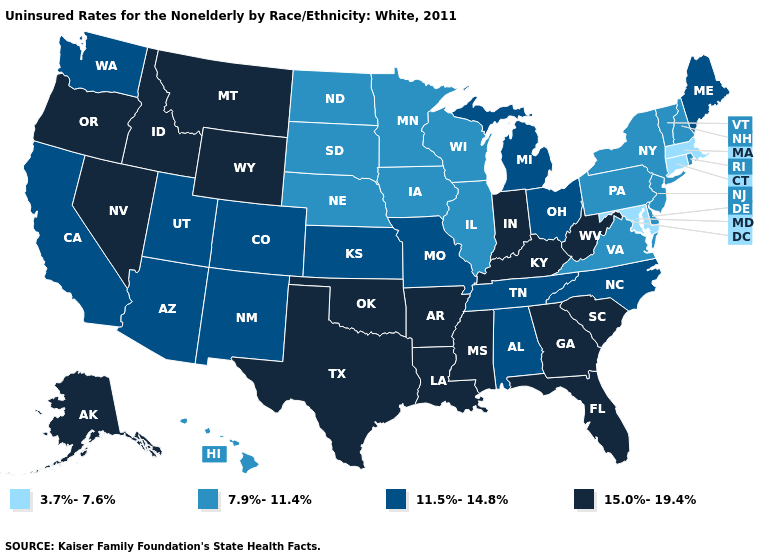What is the highest value in states that border Kansas?
Be succinct. 15.0%-19.4%. What is the highest value in the USA?
Concise answer only. 15.0%-19.4%. What is the value of Illinois?
Give a very brief answer. 7.9%-11.4%. What is the value of Arizona?
Give a very brief answer. 11.5%-14.8%. Does Oklahoma have a higher value than Louisiana?
Quick response, please. No. What is the value of North Dakota?
Answer briefly. 7.9%-11.4%. What is the lowest value in states that border Ohio?
Concise answer only. 7.9%-11.4%. Among the states that border Colorado , which have the highest value?
Concise answer only. Oklahoma, Wyoming. How many symbols are there in the legend?
Answer briefly. 4. Name the states that have a value in the range 7.9%-11.4%?
Keep it brief. Delaware, Hawaii, Illinois, Iowa, Minnesota, Nebraska, New Hampshire, New Jersey, New York, North Dakota, Pennsylvania, Rhode Island, South Dakota, Vermont, Virginia, Wisconsin. Does Washington have the highest value in the West?
Be succinct. No. Name the states that have a value in the range 3.7%-7.6%?
Give a very brief answer. Connecticut, Maryland, Massachusetts. What is the value of New Jersey?
Concise answer only. 7.9%-11.4%. Which states have the lowest value in the USA?
Quick response, please. Connecticut, Maryland, Massachusetts. Which states have the lowest value in the West?
Give a very brief answer. Hawaii. 